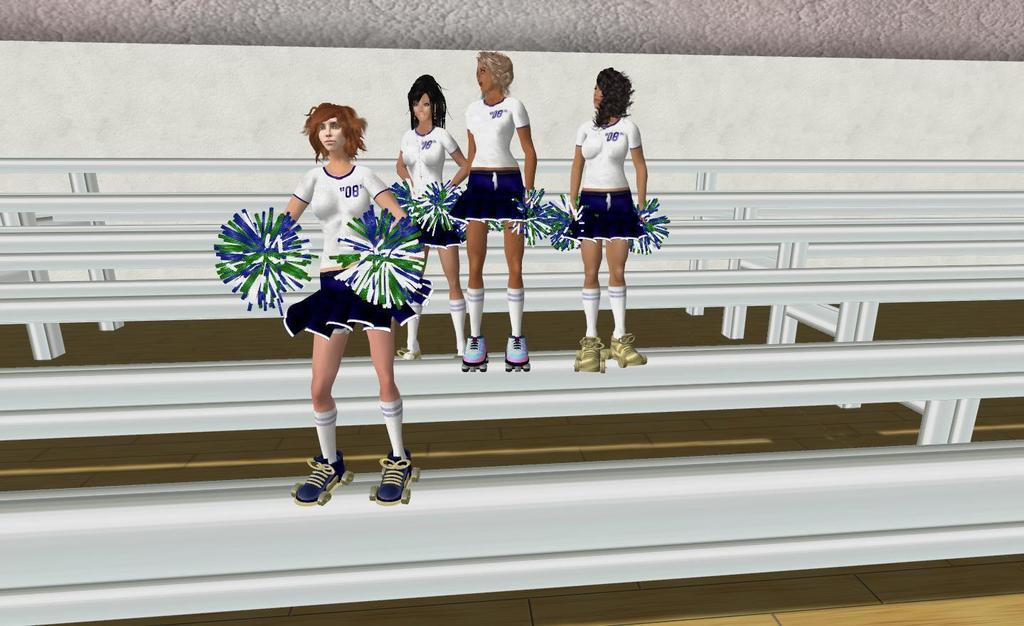What type of picture is in the image? The image contains an animated picture. What is happening in the animated picture? The animated picture depicts a group of women. What are the women wearing? The women are wearing skates. What are the women holding? The women are holding pom poms. What are the women standing on? The women are standing on poles. How does the image show the women expressing their hate towards each other? The image does not show the women expressing hate towards each other; they are depicted as a group performing a synchronized activity. 